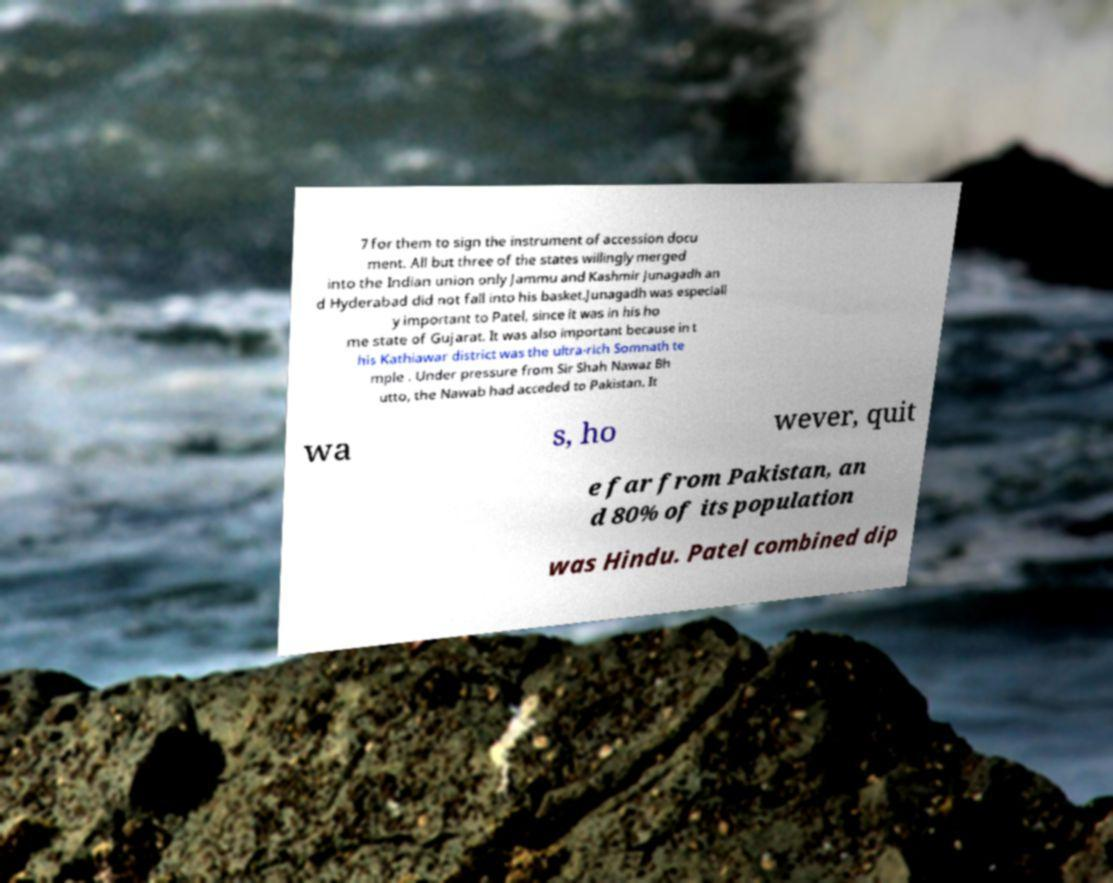For documentation purposes, I need the text within this image transcribed. Could you provide that? 7 for them to sign the instrument of accession docu ment. All but three of the states willingly merged into the Indian union only Jammu and Kashmir Junagadh an d Hyderabad did not fall into his basket.Junagadh was especiall y important to Patel, since it was in his ho me state of Gujarat. It was also important because in t his Kathiawar district was the ultra-rich Somnath te mple . Under pressure from Sir Shah Nawaz Bh utto, the Nawab had acceded to Pakistan. It wa s, ho wever, quit e far from Pakistan, an d 80% of its population was Hindu. Patel combined dip 